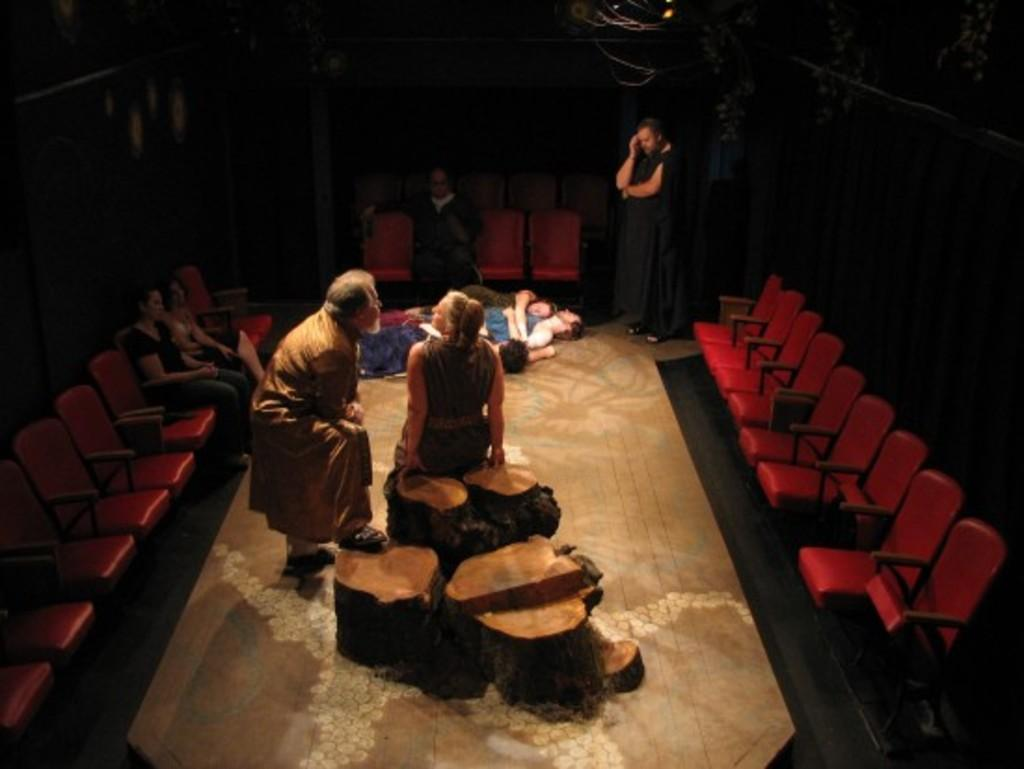What are the people in the image doing with the chairs? There are people standing on chairs and sitting on chairs in the image. Are there any people not using chairs in the image? Yes, there are people lying on the floor in the image. Can you see a giraffe wearing a ring in the image? No, there is no giraffe or ring present in the image. 